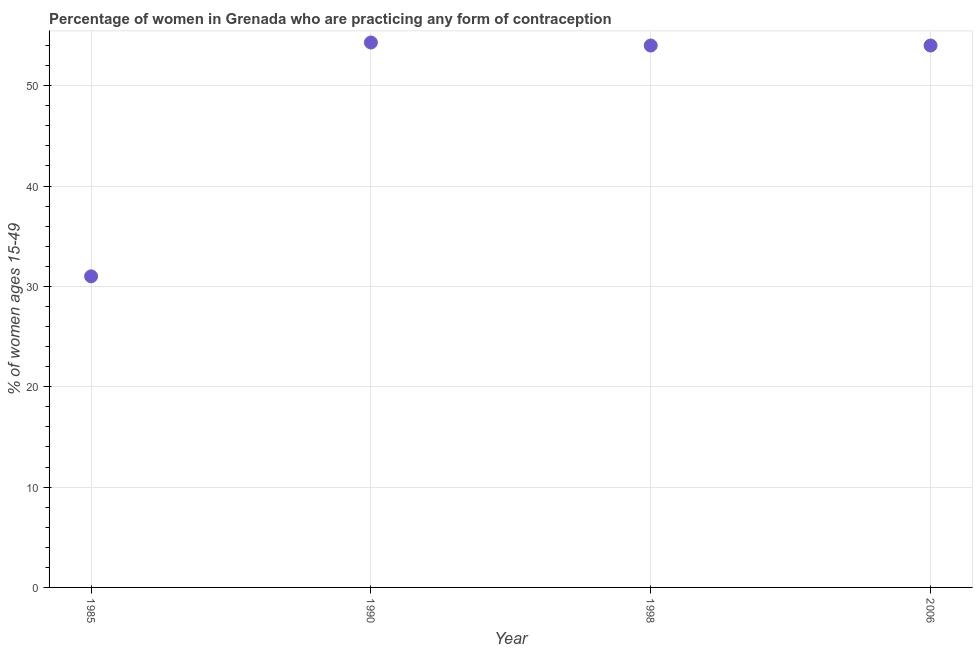What is the contraceptive prevalence in 2006?
Provide a short and direct response. 54. Across all years, what is the maximum contraceptive prevalence?
Give a very brief answer. 54.3. In which year was the contraceptive prevalence minimum?
Keep it short and to the point. 1985. What is the sum of the contraceptive prevalence?
Offer a very short reply. 193.3. What is the difference between the contraceptive prevalence in 1990 and 2006?
Provide a short and direct response. 0.3. What is the average contraceptive prevalence per year?
Your answer should be compact. 48.33. What is the median contraceptive prevalence?
Provide a succinct answer. 54. Do a majority of the years between 2006 and 1985 (inclusive) have contraceptive prevalence greater than 20 %?
Ensure brevity in your answer.  Yes. What is the ratio of the contraceptive prevalence in 1985 to that in 1998?
Your answer should be very brief. 0.57. Is the contraceptive prevalence in 1990 less than that in 1998?
Ensure brevity in your answer.  No. Is the difference between the contraceptive prevalence in 1985 and 2006 greater than the difference between any two years?
Provide a succinct answer. No. What is the difference between the highest and the second highest contraceptive prevalence?
Make the answer very short. 0.3. Is the sum of the contraceptive prevalence in 1998 and 2006 greater than the maximum contraceptive prevalence across all years?
Your answer should be very brief. Yes. What is the difference between the highest and the lowest contraceptive prevalence?
Offer a very short reply. 23.3. Does the contraceptive prevalence monotonically increase over the years?
Your response must be concise. No. How many dotlines are there?
Offer a very short reply. 1. Are the values on the major ticks of Y-axis written in scientific E-notation?
Offer a very short reply. No. Does the graph contain any zero values?
Your answer should be very brief. No. What is the title of the graph?
Give a very brief answer. Percentage of women in Grenada who are practicing any form of contraception. What is the label or title of the X-axis?
Offer a very short reply. Year. What is the label or title of the Y-axis?
Keep it short and to the point. % of women ages 15-49. What is the % of women ages 15-49 in 1990?
Give a very brief answer. 54.3. What is the % of women ages 15-49 in 1998?
Provide a succinct answer. 54. What is the difference between the % of women ages 15-49 in 1985 and 1990?
Your response must be concise. -23.3. What is the difference between the % of women ages 15-49 in 1985 and 2006?
Provide a short and direct response. -23. What is the difference between the % of women ages 15-49 in 1990 and 1998?
Give a very brief answer. 0.3. What is the difference between the % of women ages 15-49 in 1990 and 2006?
Keep it short and to the point. 0.3. What is the ratio of the % of women ages 15-49 in 1985 to that in 1990?
Provide a succinct answer. 0.57. What is the ratio of the % of women ages 15-49 in 1985 to that in 1998?
Your answer should be very brief. 0.57. What is the ratio of the % of women ages 15-49 in 1985 to that in 2006?
Keep it short and to the point. 0.57. 